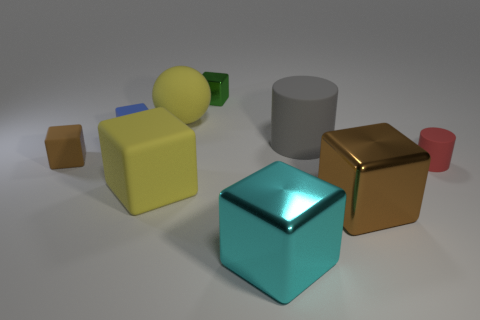Add 1 yellow metal blocks. How many objects exist? 10 Subtract all small blue matte blocks. How many blocks are left? 5 Subtract 1 balls. How many balls are left? 0 Subtract all blue spheres. How many brown cubes are left? 2 Subtract all blue balls. Subtract all red blocks. How many balls are left? 1 Subtract all tiny blue rubber objects. Subtract all large yellow objects. How many objects are left? 6 Add 5 tiny blue rubber cubes. How many tiny blue rubber cubes are left? 6 Add 6 small red rubber objects. How many small red rubber objects exist? 7 Subtract all yellow cubes. How many cubes are left? 5 Subtract 1 gray cylinders. How many objects are left? 8 